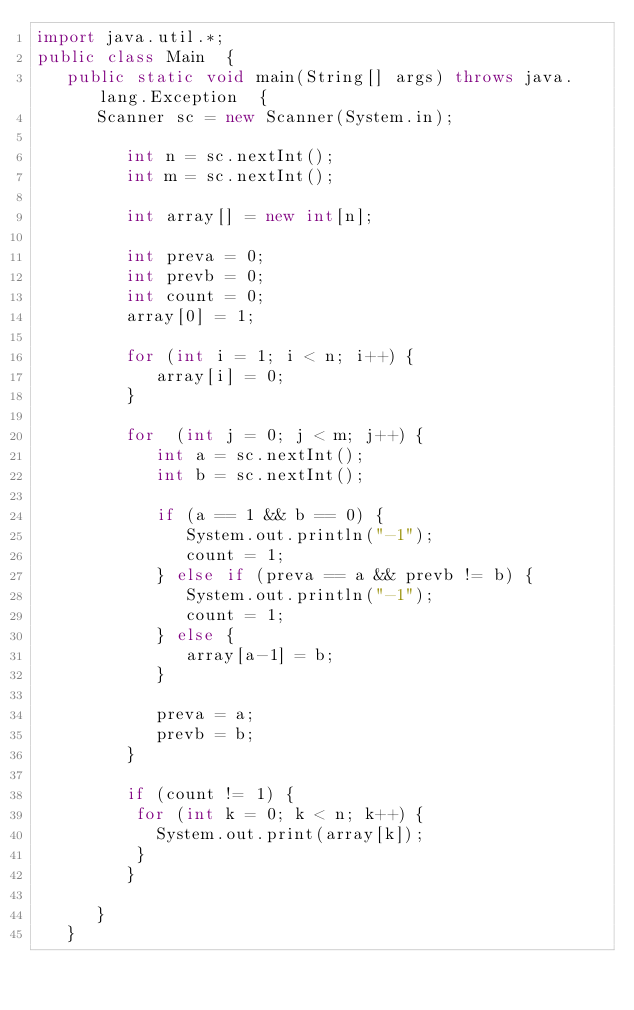Convert code to text. <code><loc_0><loc_0><loc_500><loc_500><_Java_>import java.util.*;
public class Main  {
   public static void main(String[] args) throws java.lang.Exception  {
      Scanner sc = new Scanner(System.in);
      
         int n = sc.nextInt();
         int m = sc.nextInt();
         
         int array[] = new int[n];
         
         int preva = 0;
         int prevb = 0;
         int count = 0;
         array[0] = 1;
         
         for (int i = 1; i < n; i++) {
            array[i] = 0;
         }
            
         for  (int j = 0; j < m; j++) {
            int a = sc.nextInt();
            int b = sc.nextInt();
              
            if (a == 1 && b == 0) {
               System.out.println("-1");
               count = 1;
            } else if (preva == a && prevb != b) {
               System.out.println("-1");
               count = 1;
            } else {
               array[a-1] = b;  
            }
            
            preva = a;
            prevb = b;
         }
         
         if (count != 1) {
          for (int k = 0; k < n; k++) {
            System.out.print(array[k]);
          }
         }
        
      }          
   }
</code> 